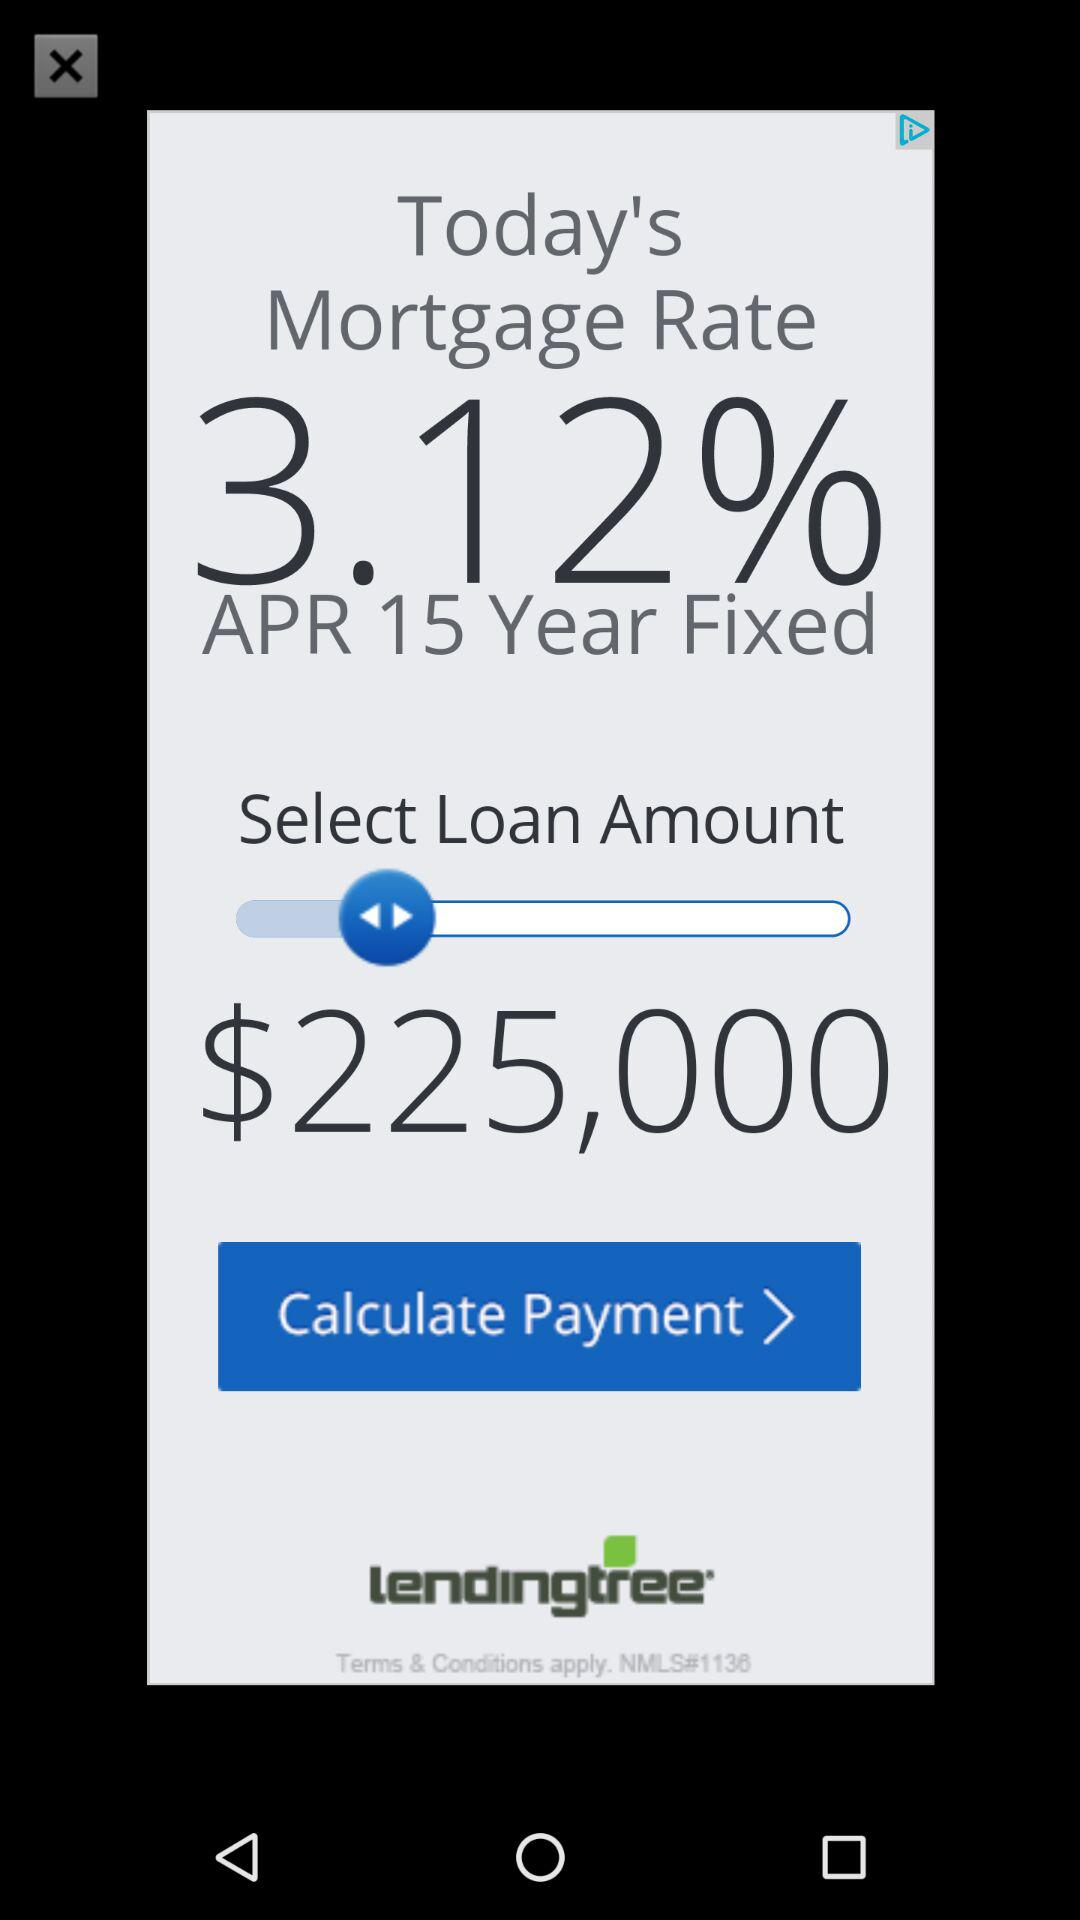What is the name of the application? The name of the application is "lendingtree". 